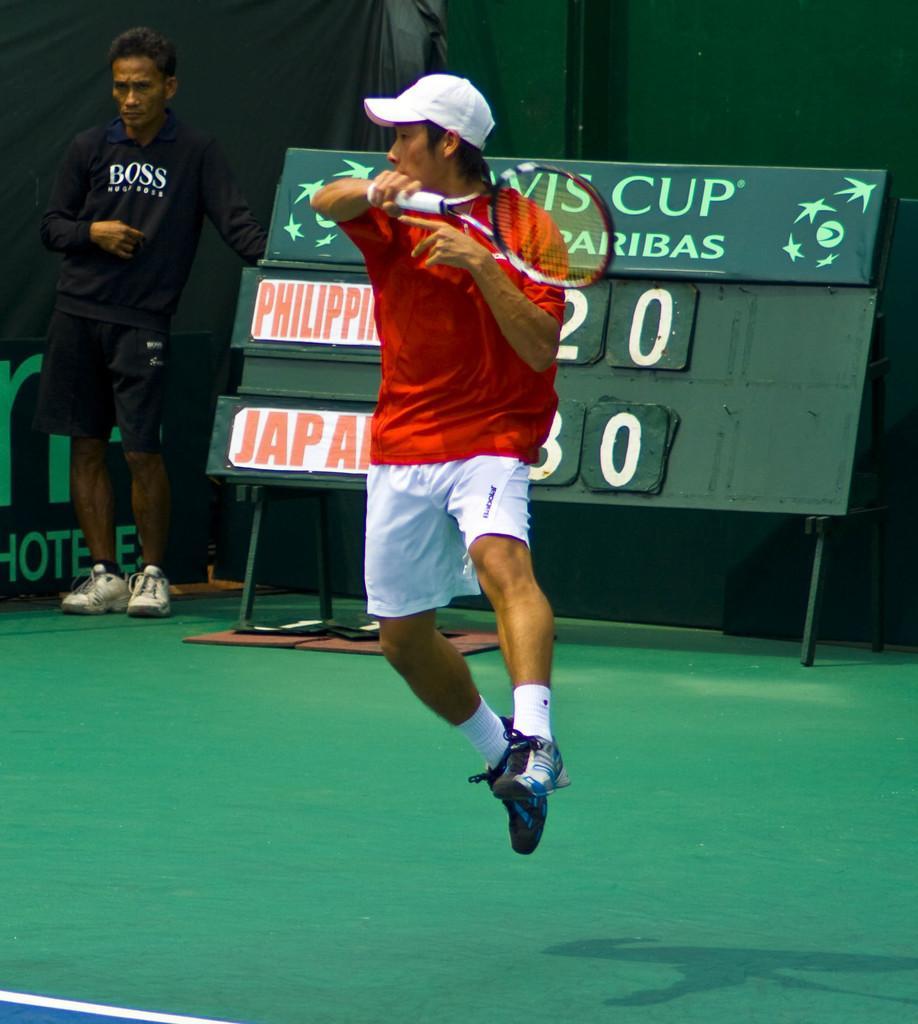Can you describe this image briefly? This picture shows man playing tennis with racket and we see a man standing on the back 